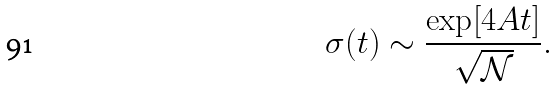Convert formula to latex. <formula><loc_0><loc_0><loc_500><loc_500>\sigma ( t ) \sim \frac { \exp [ 4 A t ] } { \sqrt { \mathcal { N } } } .</formula> 